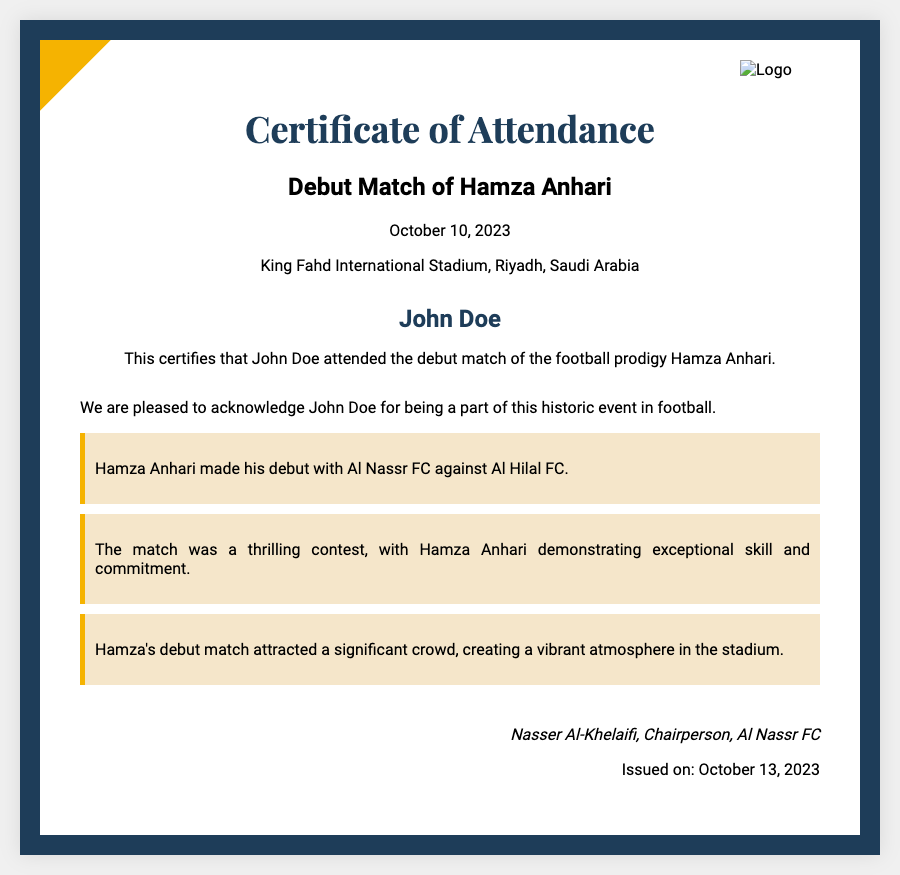What is the title of the certificate? The title of the certificate is stated at the top of the document, being an acknowledgment of attendance.
Answer: Certificate of Attendance Who attended Hamza Anhari's debut match? The recipient's name is explicitly mentioned in the document, representing the individual who attended the match.
Answer: John Doe On what date did Hamza Anhari make his debut? The date is listed in the document, corresponding to when the event took place.
Answer: October 10, 2023 Where did the debut match take place? The location of the match is specified in the document, indicating the venue for the historic event.
Answer: King Fahd International Stadium, Riyadh, Saudi Arabia Who signed the certificate? The document includes the name and title of the person who authorized the certificate, confirming its authenticity.
Answer: Nasser Al-Khelaifi What team did Hamza Anhari debut with? The document mentions the football club affiliated with Hamza Anhari, identifying the team he debuted for.
Answer: Al Nassr FC What was the opposing team in the debut match? The opposing team is noted in the document, establishing the context of the match Hamza played.
Answer: Al Hilal FC How many days after the debut match was the certificate issued? The issuing date is provided in the document, which can help calculate the duration between the match date and the certificate issuance.
Answer: 3 days 